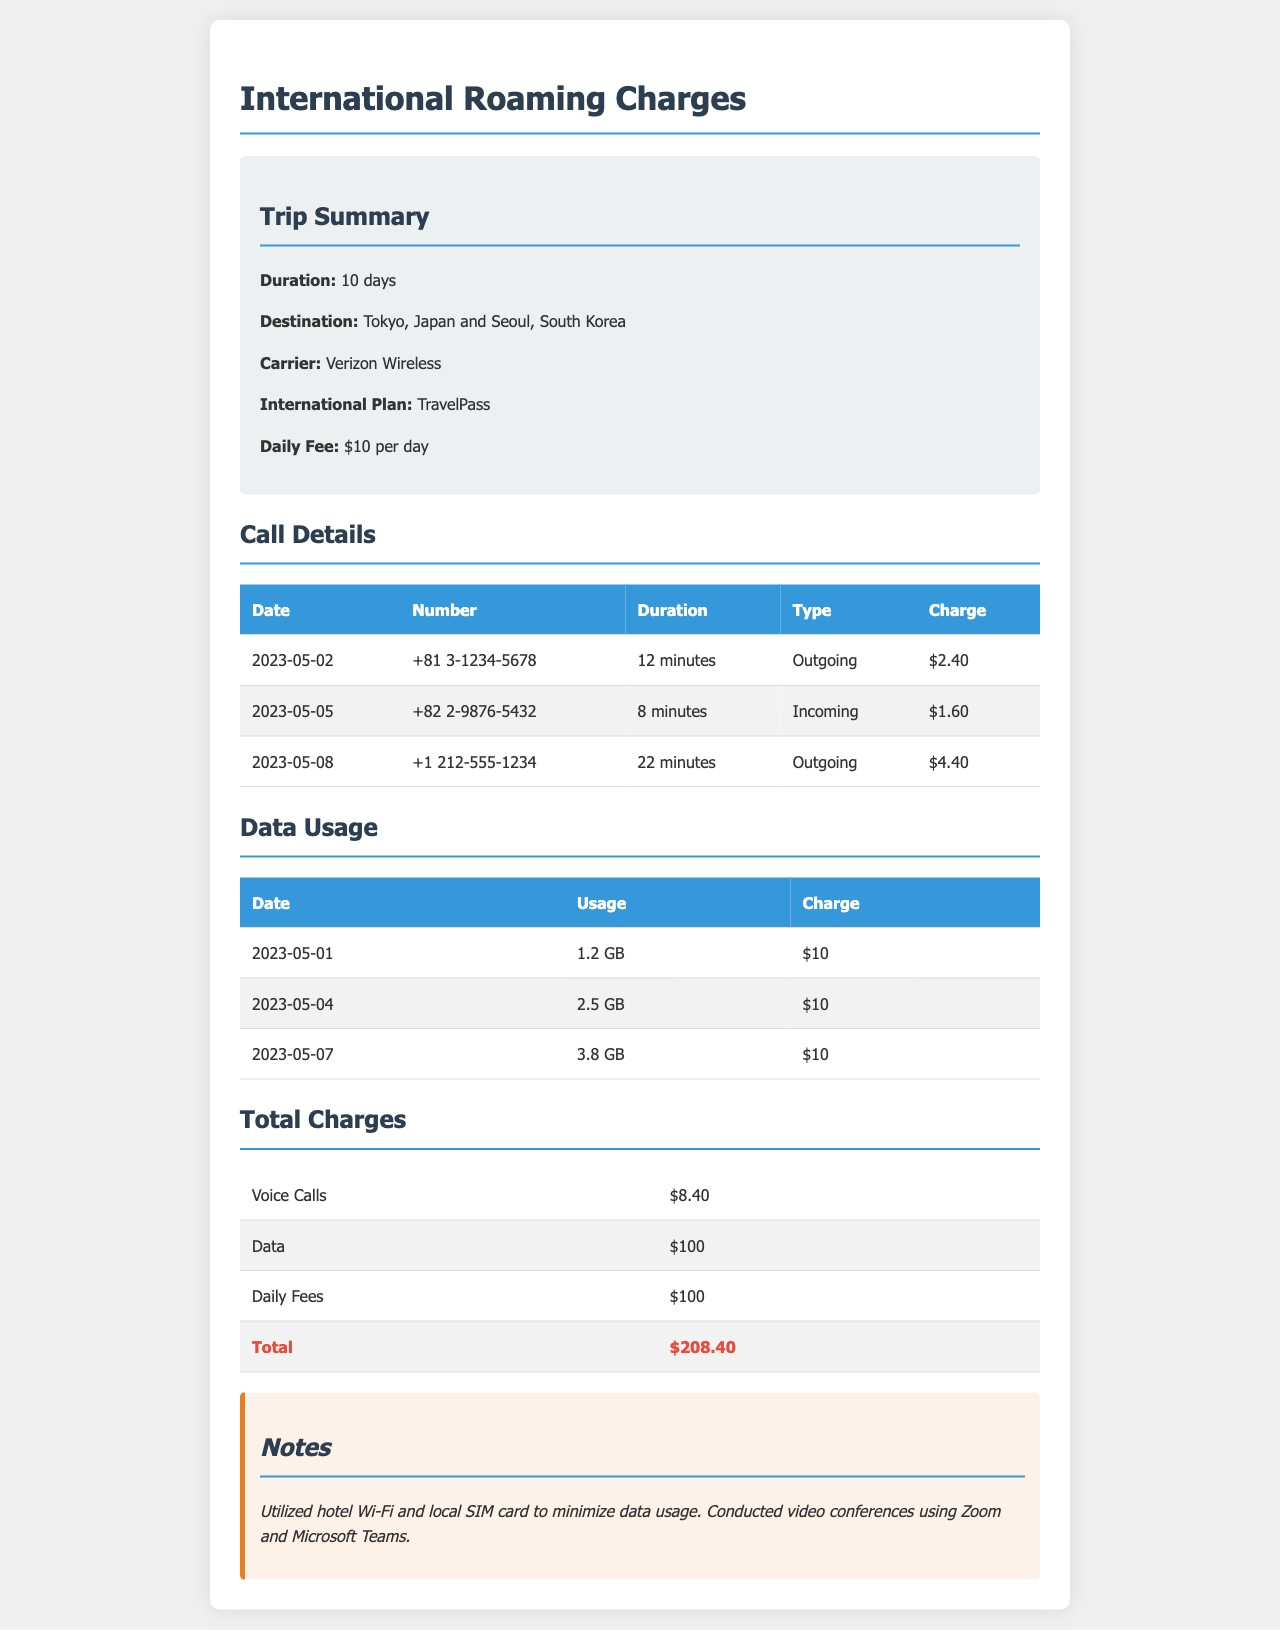What is the duration of the trip? The duration of the trip, as stated in the document, is 10 days.
Answer: 10 days What was the daily fee for the roaming plan? The document mentions the daily fee for the TravelPass plan is $10 per day.
Answer: $10 How much was charged for voice calls? The total charge for voice calls is provided in the total charges section, which is $8.40.
Answer: $8.40 What locations were visited during the trip? The document lists the destinations as Tokyo, Japan and Seoul, South Korea.
Answer: Tokyo, Japan and Seoul, South Korea What was the total charge for data usage? The document specifies that the total charge for data is $100.
Answer: $100 What type of international plan was used? The document states the international plan used was TravelPass.
Answer: TravelPass How many minutes of outgoing calls were made? By adding the durations of all outgoing calls from the table, the total is calculated as 12 + 22 = 34 minutes.
Answer: 34 minutes What is the total amount of daily fees incurred? The daily fee for 10 days at $10 per day is calculated as 10 x $10 = $100.
Answer: $100 Which applications were utilized for video conferences? The document notes that Zoom and Microsoft Teams were used for video conferences.
Answer: Zoom and Microsoft Teams 